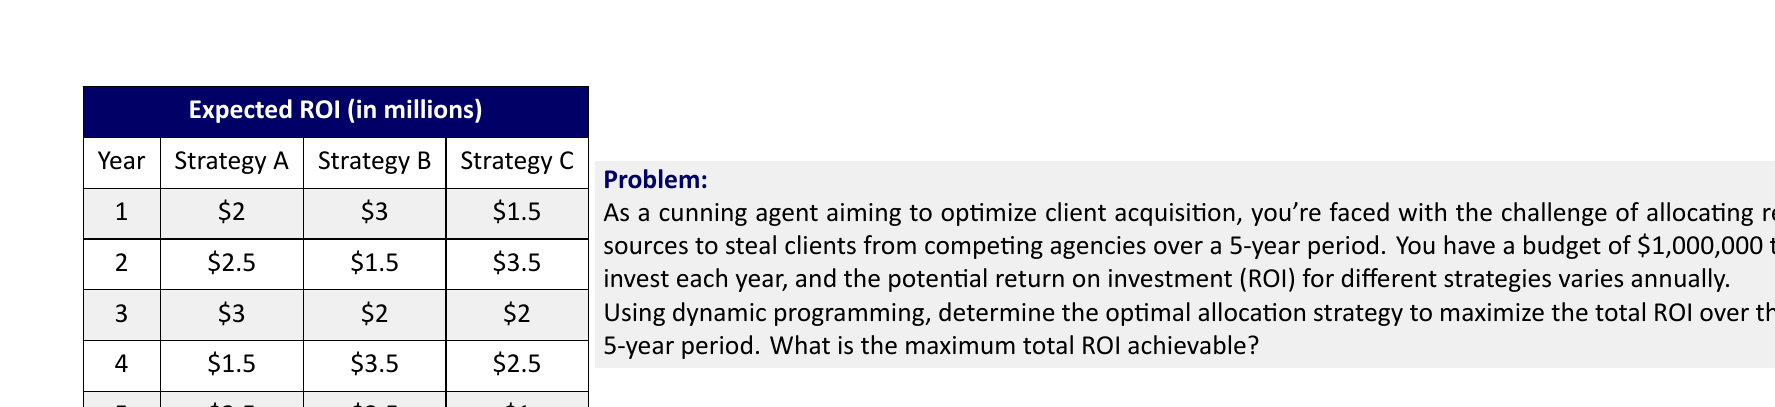Show me your answer to this math problem. To solve this problem using dynamic programming, we'll use the following approach:

1. Define the subproblem: Let $f(n)$ be the maximum ROI achievable from year $n$ to year 5.

2. Establish the recurrence relation:
   $$f(n) = \max(\text{Strategy A}_n + f(n+1), \text{Strategy B}_n + f(n+1), \text{Strategy C}_n + f(n+1))$$
   where $\text{Strategy X}_n$ represents the ROI for Strategy X in year $n$.

3. Base case: $f(6) = 0$ (as there are no years after year 5)

4. Solve the subproblems bottom-up:

   For year 5:
   $$f(5) = \max(3.5, 2.5, 1) = 3.5$$
   Optimal strategy: A

   For year 4:
   $$f(4) = \max(1.5 + 3.5, 3.5 + 3.5, 2.5 + 3.5) = 7$$
   Optimal strategy: B

   For year 3:
   $$f(3) = \max(3 + 7, 2 + 7, 2 + 7) = 10$$
   Optimal strategy: A

   For year 2:
   $$f(2) = \max(2.5 + 10, 1.5 + 10, 3.5 + 10) = 13.5$$
   Optimal strategy: C

   For year 1:
   $$f(1) = \max(2 + 13.5, 3 + 13.5, 1.5 + 13.5) = 16.5$$
   Optimal strategy: B

5. The maximum total ROI achievable is $f(1) = 16.5$ million.

6. To determine the optimal allocation strategy, we trace back the decisions:
   Year 1: Strategy B
   Year 2: Strategy C
   Year 3: Strategy A
   Year 4: Strategy B
   Year 5: Strategy A

Therefore, the optimal allocation strategy to maximize the total ROI over the 5-year period is B-C-A-B-A, resulting in a maximum total ROI of $16.5 million.
Answer: $16.5 million 